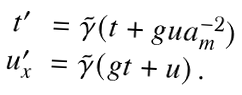<formula> <loc_0><loc_0><loc_500><loc_500>\begin{array} { c l } t ^ { \prime } & = \tilde { \gamma } ( t + g u a _ { m } ^ { - 2 } ) \\ u ^ { \prime } _ { x } & = \tilde { \gamma } ( g t + u ) \, . \end{array}</formula> 